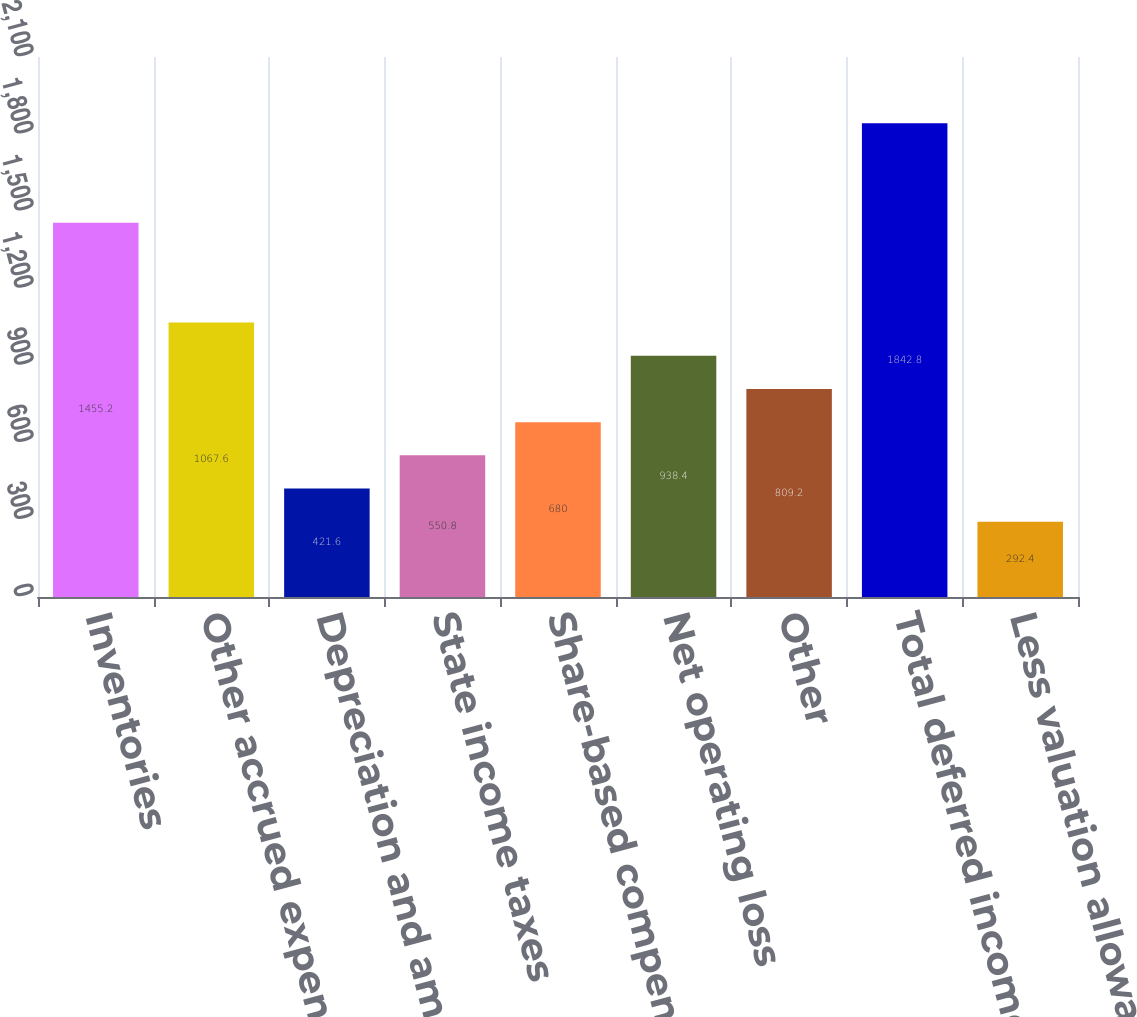<chart> <loc_0><loc_0><loc_500><loc_500><bar_chart><fcel>Inventories<fcel>Other accrued expenses<fcel>Depreciation and amortization<fcel>State income taxes<fcel>Share-based compensation<fcel>Net operating loss<fcel>Other<fcel>Total deferred income tax<fcel>Less valuation allowances<nl><fcel>1455.2<fcel>1067.6<fcel>421.6<fcel>550.8<fcel>680<fcel>938.4<fcel>809.2<fcel>1842.8<fcel>292.4<nl></chart> 